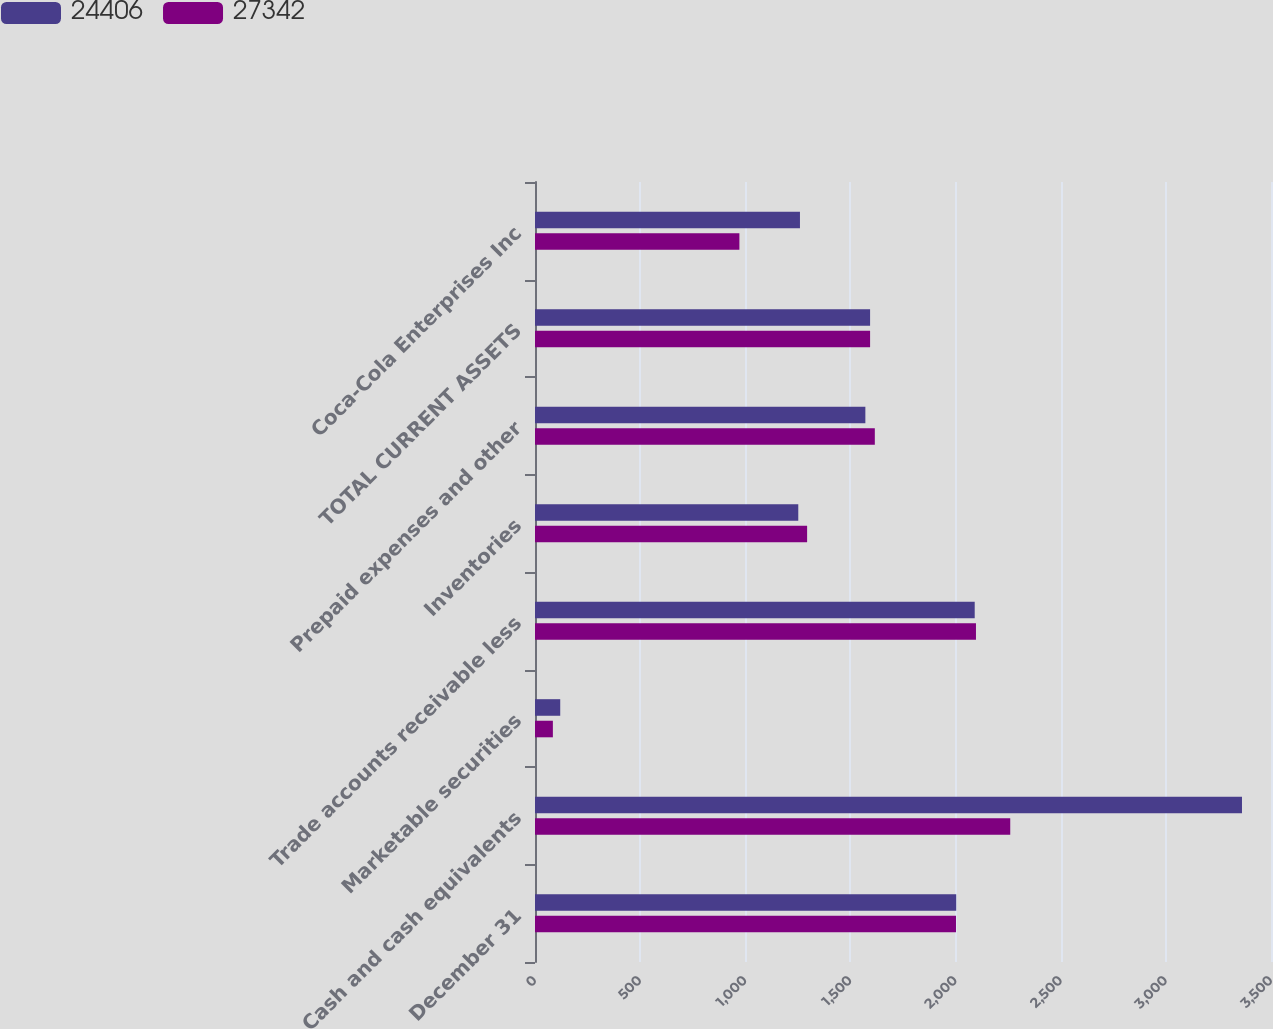Convert chart. <chart><loc_0><loc_0><loc_500><loc_500><stacked_bar_chart><ecel><fcel>December 31<fcel>Cash and cash equivalents<fcel>Marketable securities<fcel>Trade accounts receivable less<fcel>Inventories<fcel>Prepaid expenses and other<fcel>TOTAL CURRENT ASSETS<fcel>Coca-Cola Enterprises Inc<nl><fcel>24406<fcel>2003<fcel>3362<fcel>120<fcel>2091<fcel>1252<fcel>1571<fcel>1593.5<fcel>1260<nl><fcel>27342<fcel>2002<fcel>2260<fcel>85<fcel>2097<fcel>1294<fcel>1616<fcel>1593.5<fcel>972<nl></chart> 